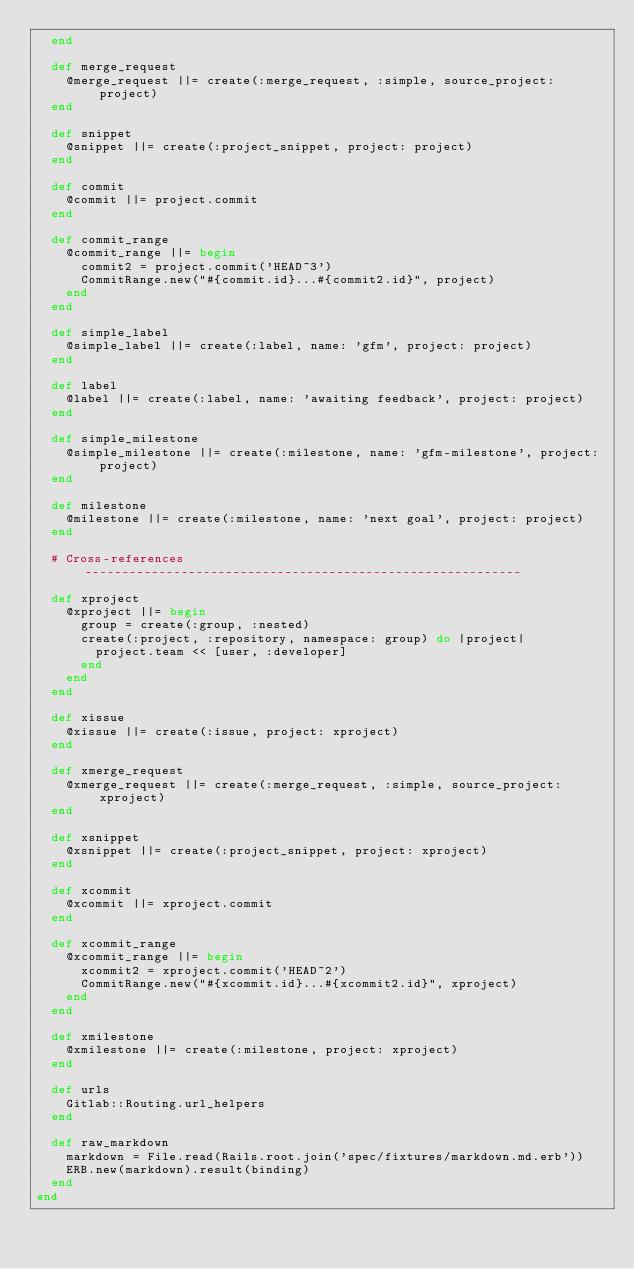Convert code to text. <code><loc_0><loc_0><loc_500><loc_500><_Ruby_>  end

  def merge_request
    @merge_request ||= create(:merge_request, :simple, source_project: project)
  end

  def snippet
    @snippet ||= create(:project_snippet, project: project)
  end

  def commit
    @commit ||= project.commit
  end

  def commit_range
    @commit_range ||= begin
      commit2 = project.commit('HEAD~3')
      CommitRange.new("#{commit.id}...#{commit2.id}", project)
    end
  end

  def simple_label
    @simple_label ||= create(:label, name: 'gfm', project: project)
  end

  def label
    @label ||= create(:label, name: 'awaiting feedback', project: project)
  end

  def simple_milestone
    @simple_milestone ||= create(:milestone, name: 'gfm-milestone', project: project)
  end

  def milestone
    @milestone ||= create(:milestone, name: 'next goal', project: project)
  end

  # Cross-references -----------------------------------------------------------

  def xproject
    @xproject ||= begin
      group = create(:group, :nested)
      create(:project, :repository, namespace: group) do |project|
        project.team << [user, :developer]
      end
    end
  end

  def xissue
    @xissue ||= create(:issue, project: xproject)
  end

  def xmerge_request
    @xmerge_request ||= create(:merge_request, :simple, source_project: xproject)
  end

  def xsnippet
    @xsnippet ||= create(:project_snippet, project: xproject)
  end

  def xcommit
    @xcommit ||= xproject.commit
  end

  def xcommit_range
    @xcommit_range ||= begin
      xcommit2 = xproject.commit('HEAD~2')
      CommitRange.new("#{xcommit.id}...#{xcommit2.id}", xproject)
    end
  end

  def xmilestone
    @xmilestone ||= create(:milestone, project: xproject)
  end

  def urls
    Gitlab::Routing.url_helpers
  end

  def raw_markdown
    markdown = File.read(Rails.root.join('spec/fixtures/markdown.md.erb'))
    ERB.new(markdown).result(binding)
  end
end
</code> 